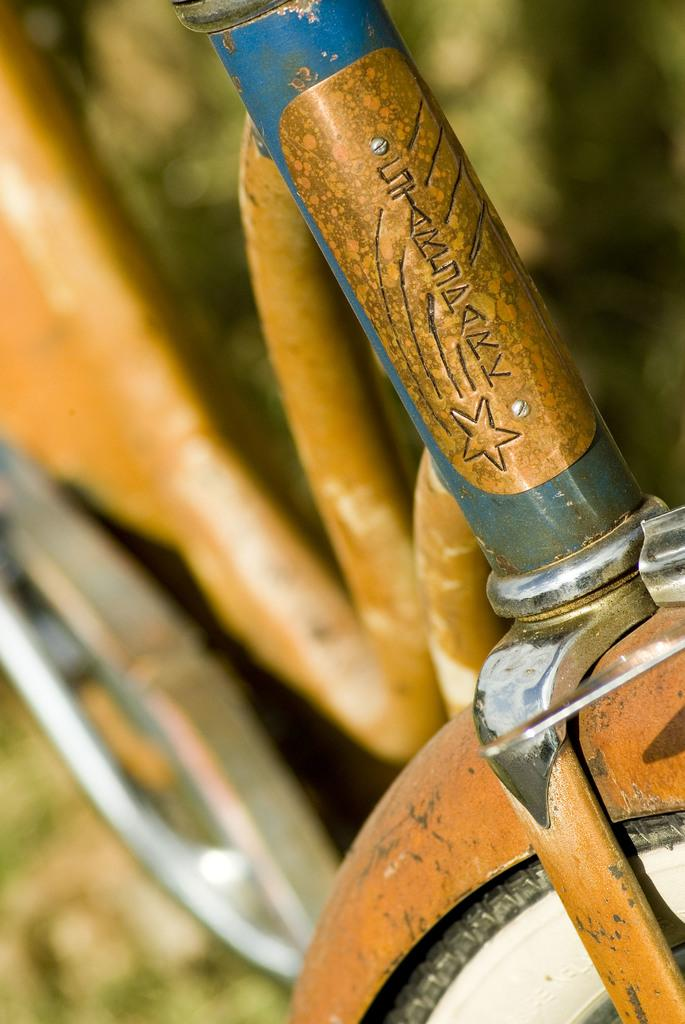What is the main object in the image? There is a bicycle in the image. Where is the bicycle located? The bicycle is on the ground. Is there any text or writing on the bicycle? Yes, there is writing on the front of the bicycle. What type of cord is attached to the bicycle in the image? There is no cord attached to the bicycle in the image. What kind of lunch is being prepared on the bicycle in the image? There is no lunch preparation or any food-related activity depicted in the image. 